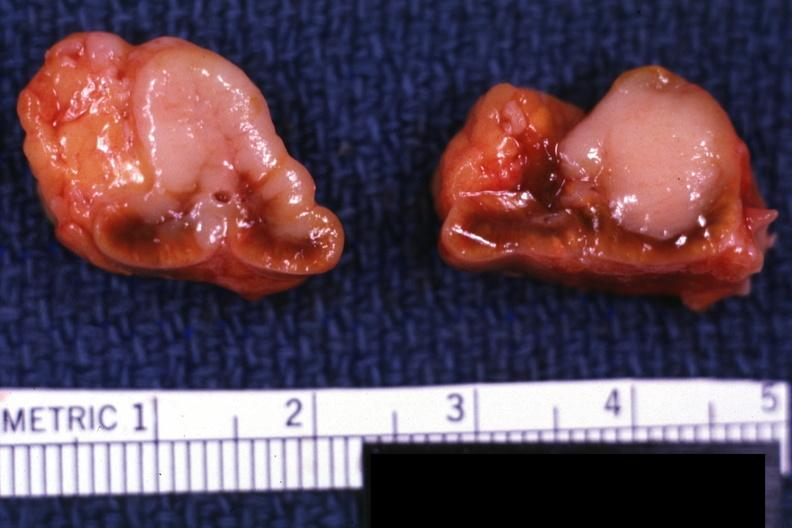what is slide 6911 and bone metastatsis?
Answer the question using a single word or phrase. Primary 